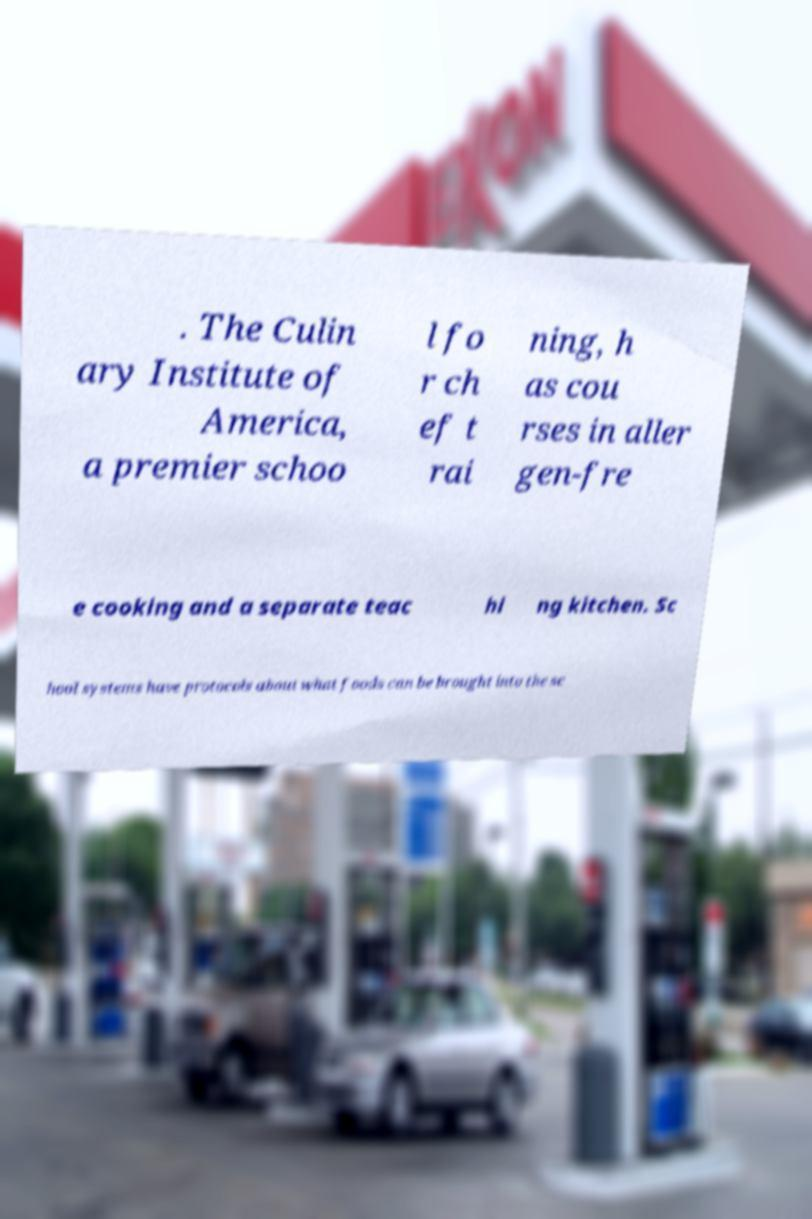Can you accurately transcribe the text from the provided image for me? . The Culin ary Institute of America, a premier schoo l fo r ch ef t rai ning, h as cou rses in aller gen-fre e cooking and a separate teac hi ng kitchen. Sc hool systems have protocols about what foods can be brought into the sc 